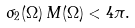Convert formula to latex. <formula><loc_0><loc_0><loc_500><loc_500>\sigma _ { 2 } ( \Omega ) \, M ( \Omega ) < 4 \pi .</formula> 